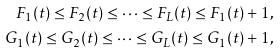Convert formula to latex. <formula><loc_0><loc_0><loc_500><loc_500>F _ { 1 } ( t ) \leq F _ { 2 } ( t ) \leq \dots \leq F _ { L } ( t ) \leq F _ { 1 } ( t ) + 1 , \\ G _ { 1 } ( t ) \leq G _ { 2 } ( t ) \leq \dots \leq G _ { L } ( t ) \leq G _ { 1 } ( t ) + 1 ,</formula> 